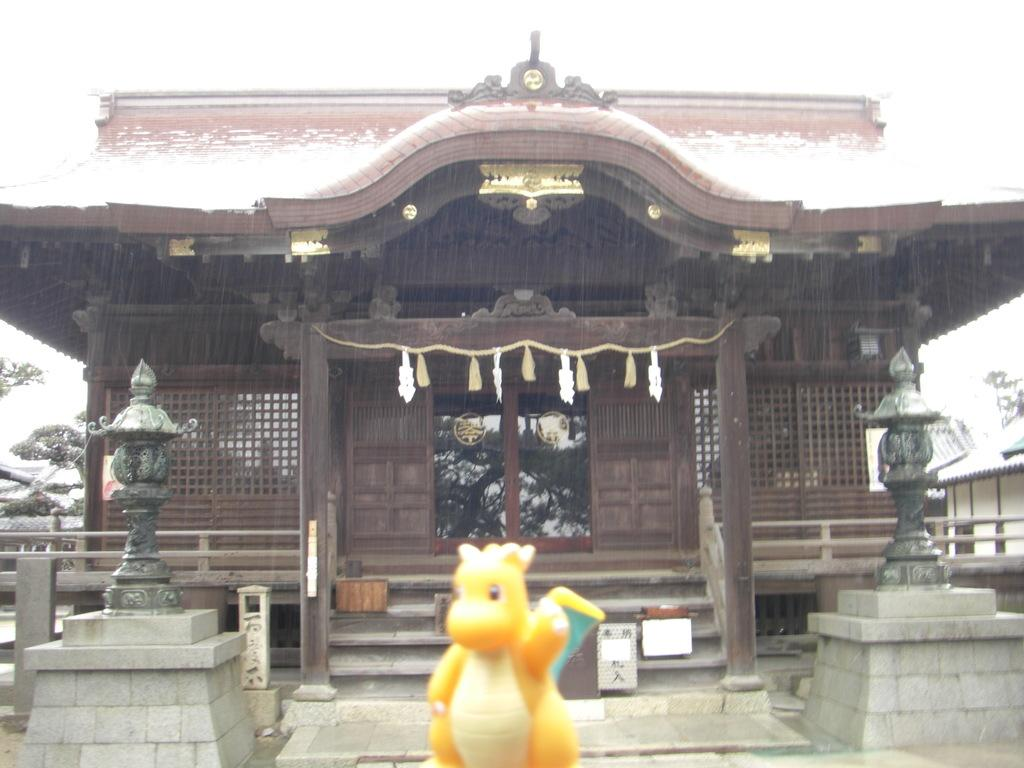What is the color of the house in the image? The house in the image is brown. What type of roof does the house have? The house has roof tiles. What can be seen in the front bottom side of the image? There is a yellow color toy in the front bottom side of the image. What type of vacation is the house offering in the image? The image does not depict a vacation or any vacation-related information. --- 